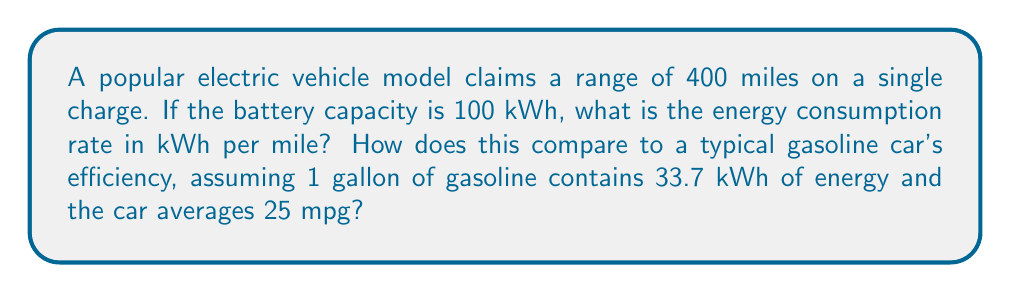Show me your answer to this math problem. Let's approach this step-by-step:

1. Calculate the energy consumption rate of the electric vehicle:
   - Range = 400 miles
   - Battery capacity = 100 kWh
   - Energy consumption rate = Battery capacity / Range
   $$ \text{Energy consumption rate} = \frac{100 \text{ kWh}}{400 \text{ miles}} = 0.25 \text{ kWh/mile} $$

2. Convert the gasoline car's efficiency to kWh/mile:
   - 1 gallon of gasoline = 33.7 kWh
   - Car efficiency = 25 mpg (miles per gallon)
   - Energy per mile = Energy per gallon / Miles per gallon
   $$ \text{Energy per mile} = \frac{33.7 \text{ kWh}}{25 \text{ miles}} = 1.348 \text{ kWh/mile} $$

3. Compare the two:
   - Electric vehicle: 0.25 kWh/mile
   - Gasoline car: 1.348 kWh/mile
   - Ratio = Gasoline car efficiency / Electric vehicle efficiency
   $$ \text{Ratio} = \frac{1.348 \text{ kWh/mile}}{0.25 \text{ kWh/mile}} = 5.392 $$

Therefore, the gasoline car uses approximately 5.392 times more energy per mile than the electric vehicle.
Answer: 0.25 kWh/mile; 5.392 times less efficient 